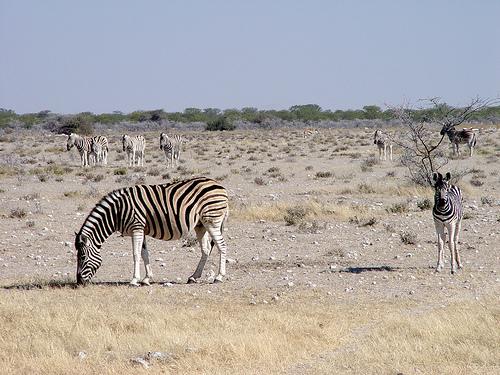Where is the water?
Quick response, please. Nowhere. Are all of the zebras facing the same direction?
Short answer required. No. How many zebras are grazing?
Concise answer only. 1. Is there water in the picture?
Short answer required. No. What country are these animals located?
Short answer required. Africa. Are the zebras facing the same way?
Quick response, please. No. 